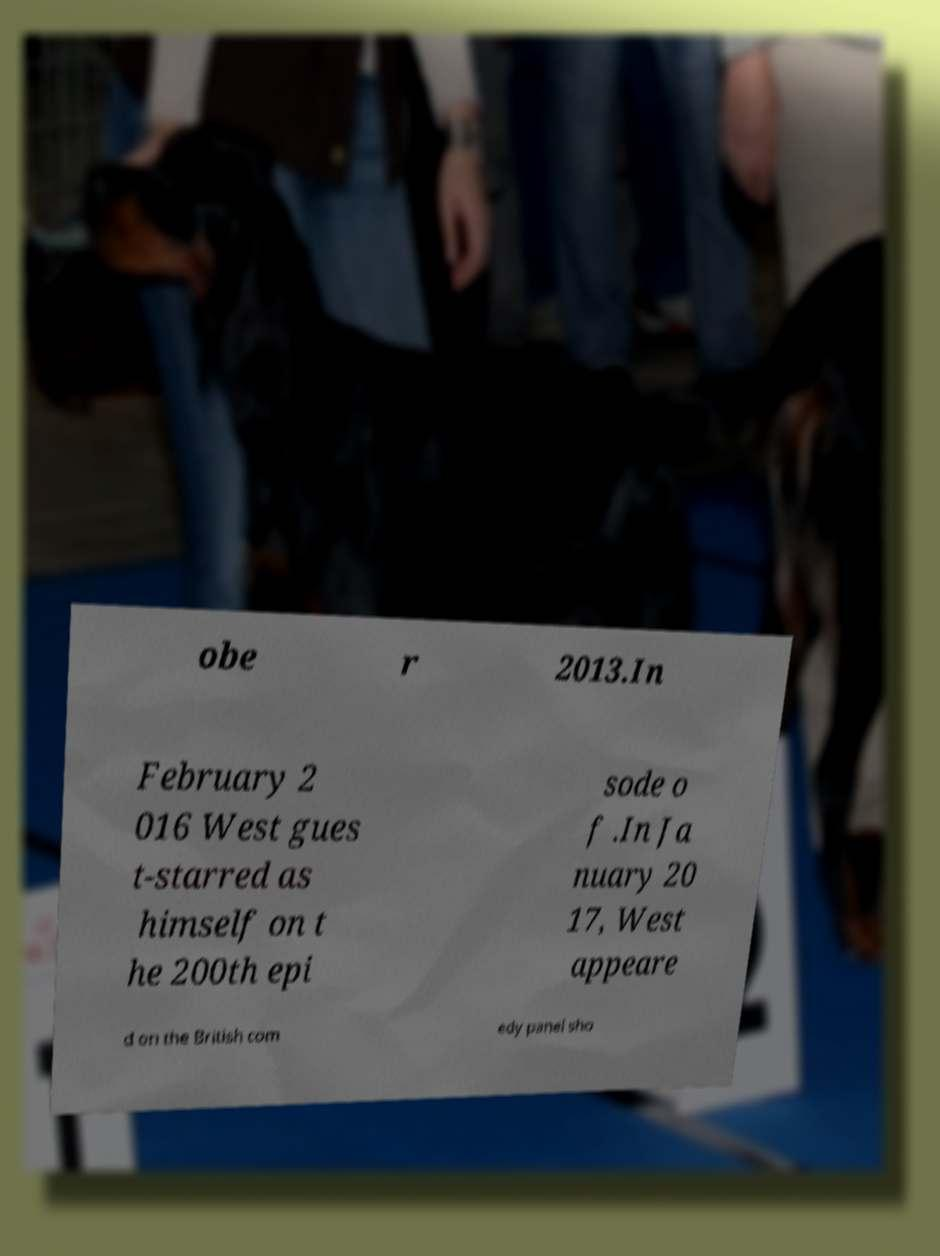For documentation purposes, I need the text within this image transcribed. Could you provide that? obe r 2013.In February 2 016 West gues t-starred as himself on t he 200th epi sode o f .In Ja nuary 20 17, West appeare d on the British com edy panel sho 